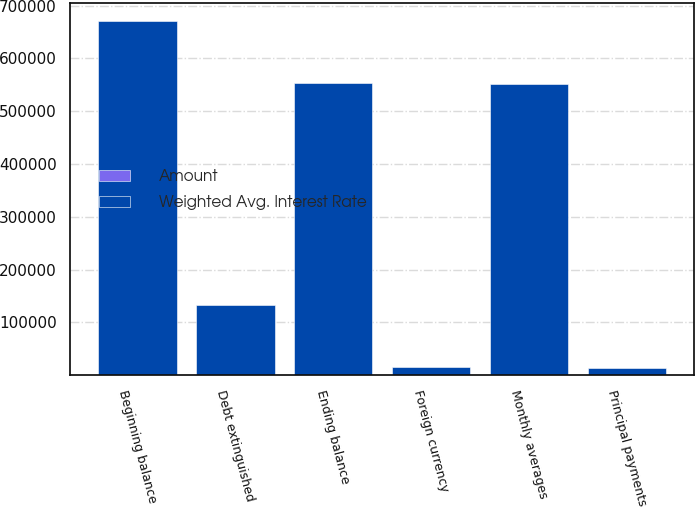<chart> <loc_0><loc_0><loc_500><loc_500><stacked_bar_chart><ecel><fcel>Beginning balance<fcel>Debt extinguished<fcel>Foreign currency<fcel>Principal payments<fcel>Ending balance<fcel>Monthly averages<nl><fcel>Weighted Avg. Interest Rate<fcel>670769<fcel>132545<fcel>15633<fcel>12719<fcel>554014<fcel>551803<nl><fcel>Amount<fcel>5.34<fcel>4.7<fcel>5.32<fcel>5.45<fcel>5.49<fcel>5.52<nl></chart> 